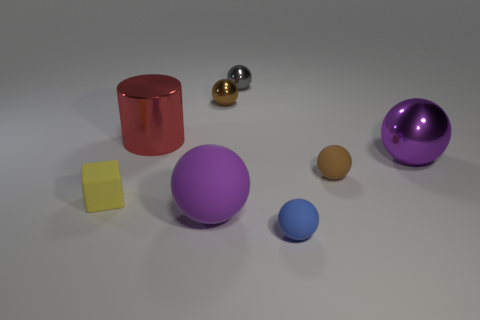Does the cube have the same color as the big metal ball?
Your answer should be compact. No. Are there more red shiny cylinders than tiny brown metallic cylinders?
Offer a terse response. Yes. The matte object that is both to the left of the gray ball and right of the yellow object has what shape?
Keep it short and to the point. Sphere. Are there any large green things?
Offer a terse response. No. There is a small gray object that is the same shape as the blue rubber thing; what is it made of?
Make the answer very short. Metal. What is the shape of the matte thing left of the large object that is behind the large purple ball that is right of the large purple rubber thing?
Provide a short and direct response. Cube. What is the material of the big ball that is the same color as the big rubber thing?
Provide a succinct answer. Metal. How many other objects are the same shape as the large purple metal thing?
Ensure brevity in your answer.  5. Do the large sphere behind the small yellow matte object and the large ball in front of the brown rubber object have the same color?
Offer a terse response. Yes. There is a yellow object that is the same size as the gray metallic ball; what material is it?
Provide a short and direct response. Rubber. 